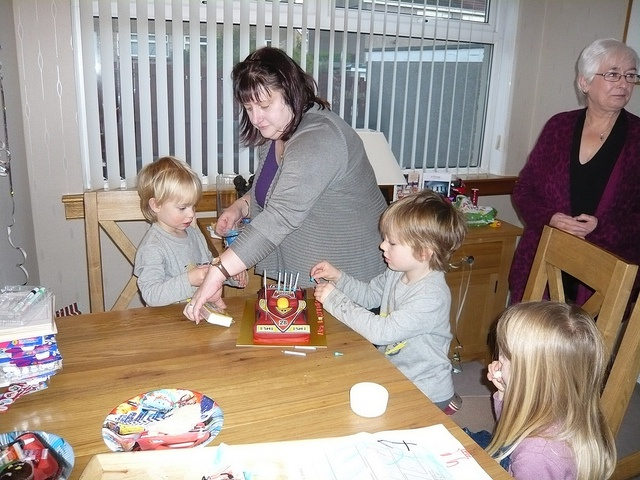Describe the objects in this image and their specific colors. I can see dining table in gray, white, and tan tones, people in gray, darkgray, black, and lightgray tones, people in gray, tan, and darkgray tones, people in gray, black, purple, and darkgray tones, and people in gray, lightgray, darkgray, and tan tones in this image. 